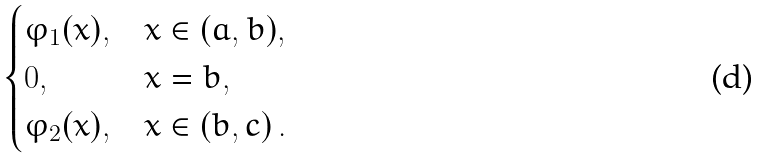Convert formula to latex. <formula><loc_0><loc_0><loc_500><loc_500>\begin{cases} \varphi _ { 1 } ( x ) , & x \in ( a , b ) , \\ 0 , & x = b , \\ \varphi _ { 2 } ( x ) , & x \in ( b , c ) \, . \end{cases}</formula> 